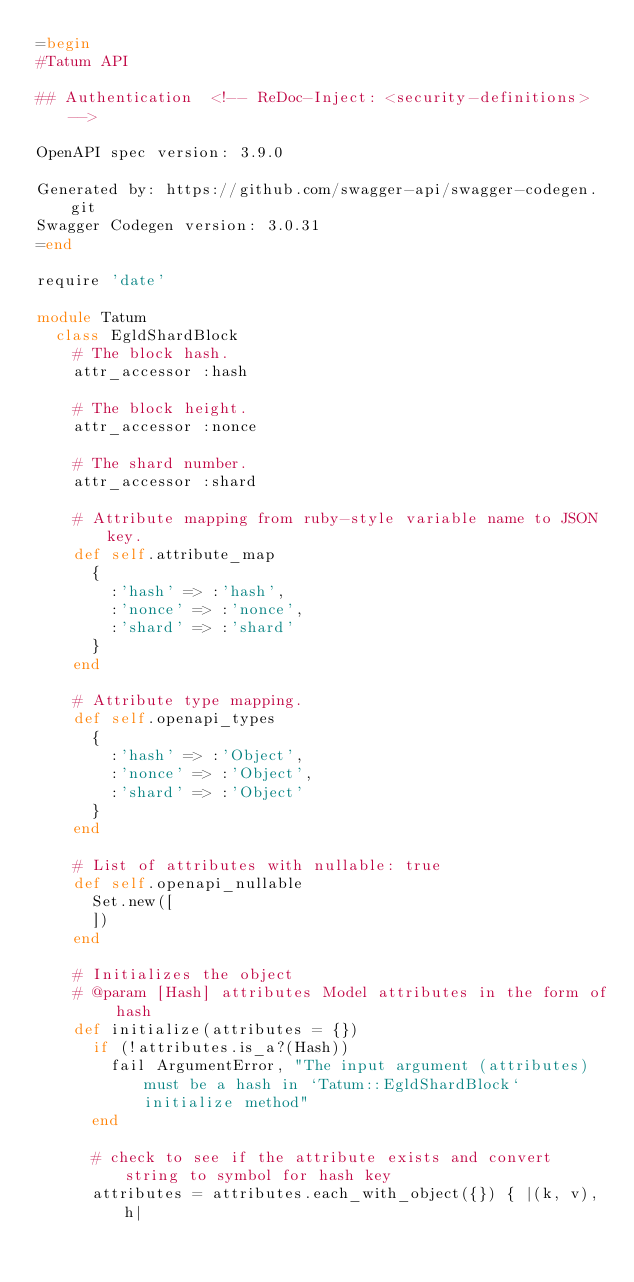Convert code to text. <code><loc_0><loc_0><loc_500><loc_500><_Ruby_>=begin
#Tatum API

## Authentication  <!-- ReDoc-Inject: <security-definitions> -->

OpenAPI spec version: 3.9.0

Generated by: https://github.com/swagger-api/swagger-codegen.git
Swagger Codegen version: 3.0.31
=end

require 'date'

module Tatum
  class EgldShardBlock
    # The block hash.
    attr_accessor :hash

    # The block height.
    attr_accessor :nonce

    # The shard number.
    attr_accessor :shard

    # Attribute mapping from ruby-style variable name to JSON key.
    def self.attribute_map
      {
        :'hash' => :'hash',
        :'nonce' => :'nonce',
        :'shard' => :'shard'
      }
    end

    # Attribute type mapping.
    def self.openapi_types
      {
        :'hash' => :'Object',
        :'nonce' => :'Object',
        :'shard' => :'Object'
      }
    end

    # List of attributes with nullable: true
    def self.openapi_nullable
      Set.new([
      ])
    end
  
    # Initializes the object
    # @param [Hash] attributes Model attributes in the form of hash
    def initialize(attributes = {})
      if (!attributes.is_a?(Hash))
        fail ArgumentError, "The input argument (attributes) must be a hash in `Tatum::EgldShardBlock` initialize method"
      end

      # check to see if the attribute exists and convert string to symbol for hash key
      attributes = attributes.each_with_object({}) { |(k, v), h|</code> 